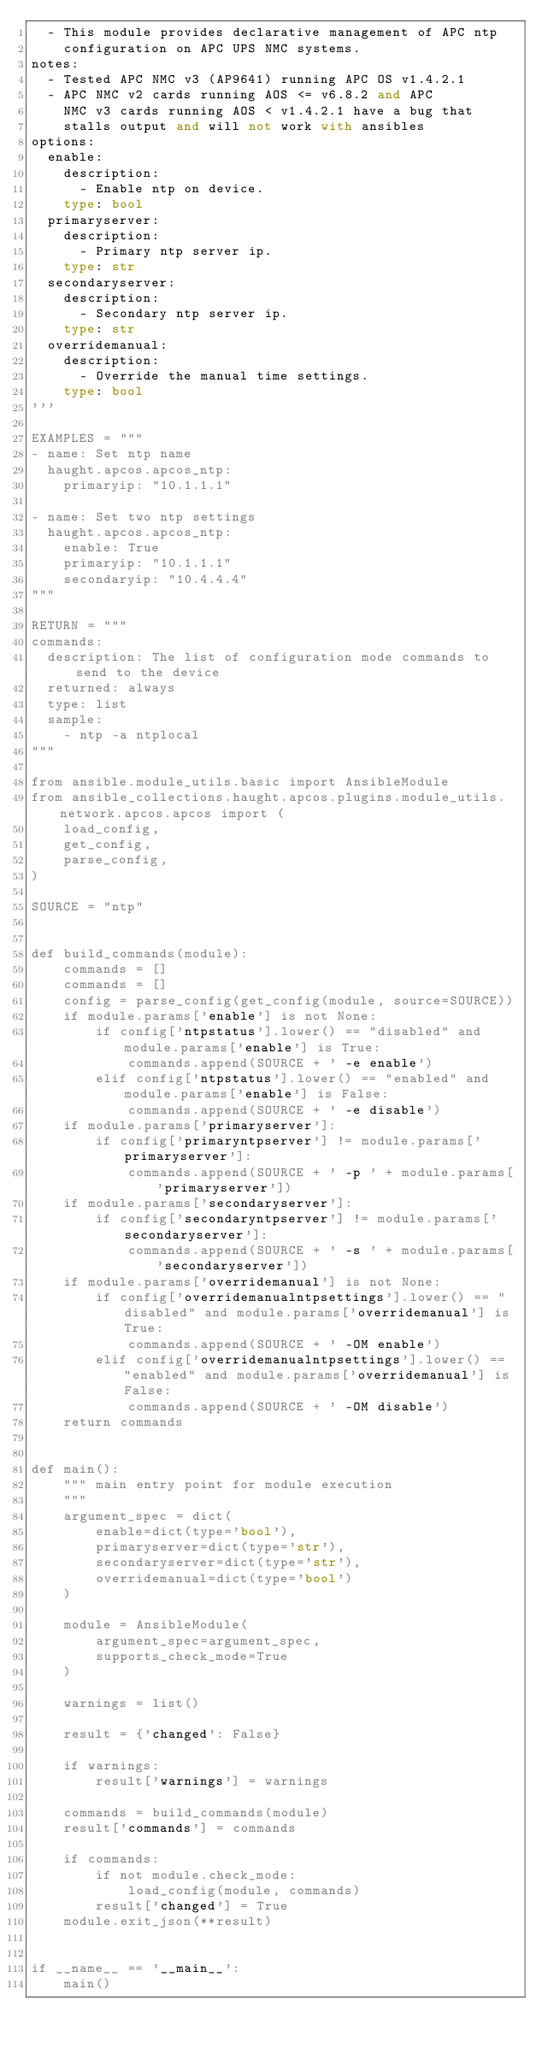Convert code to text. <code><loc_0><loc_0><loc_500><loc_500><_Python_>  - This module provides declarative management of APC ntp
    configuration on APC UPS NMC systems.
notes:
  - Tested APC NMC v3 (AP9641) running APC OS v1.4.2.1
  - APC NMC v2 cards running AOS <= v6.8.2 and APC
    NMC v3 cards running AOS < v1.4.2.1 have a bug that
    stalls output and will not work with ansibles
options:
  enable:
    description:
      - Enable ntp on device.
    type: bool
  primaryserver:
    description:
      - Primary ntp server ip.
    type: str
  secondaryserver:
    description:
      - Secondary ntp server ip.
    type: str
  overridemanual:
    description:
      - Override the manual time settings.
    type: bool
'''

EXAMPLES = """
- name: Set ntp name
  haught.apcos.apcos_ntp:
    primaryip: "10.1.1.1"

- name: Set two ntp settings
  haught.apcos.apcos_ntp:
    enable: True
    primaryip: "10.1.1.1"
    secondaryip: "10.4.4.4"
"""

RETURN = """
commands:
  description: The list of configuration mode commands to send to the device
  returned: always
  type: list
  sample:
    - ntp -a ntplocal
"""

from ansible.module_utils.basic import AnsibleModule
from ansible_collections.haught.apcos.plugins.module_utils.network.apcos.apcos import (
    load_config,
    get_config,
    parse_config,
)

SOURCE = "ntp"


def build_commands(module):
    commands = []
    commands = []
    config = parse_config(get_config(module, source=SOURCE))
    if module.params['enable'] is not None:
        if config['ntpstatus'].lower() == "disabled" and module.params['enable'] is True:
            commands.append(SOURCE + ' -e enable')
        elif config['ntpstatus'].lower() == "enabled" and module.params['enable'] is False:
            commands.append(SOURCE + ' -e disable')
    if module.params['primaryserver']:
        if config['primaryntpserver'] != module.params['primaryserver']:
            commands.append(SOURCE + ' -p ' + module.params['primaryserver'])
    if module.params['secondaryserver']:
        if config['secondaryntpserver'] != module.params['secondaryserver']:
            commands.append(SOURCE + ' -s ' + module.params['secondaryserver'])
    if module.params['overridemanual'] is not None:
        if config['overridemanualntpsettings'].lower() == "disabled" and module.params['overridemanual'] is True:
            commands.append(SOURCE + ' -OM enable')
        elif config['overridemanualntpsettings'].lower() == "enabled" and module.params['overridemanual'] is False:
            commands.append(SOURCE + ' -OM disable')
    return commands


def main():
    """ main entry point for module execution
    """
    argument_spec = dict(
        enable=dict(type='bool'),
        primaryserver=dict(type='str'),
        secondaryserver=dict(type='str'),
        overridemanual=dict(type='bool')
    )

    module = AnsibleModule(
        argument_spec=argument_spec,
        supports_check_mode=True
    )

    warnings = list()

    result = {'changed': False}

    if warnings:
        result['warnings'] = warnings

    commands = build_commands(module)
    result['commands'] = commands

    if commands:
        if not module.check_mode:
            load_config(module, commands)
        result['changed'] = True
    module.exit_json(**result)


if __name__ == '__main__':
    main()
</code> 